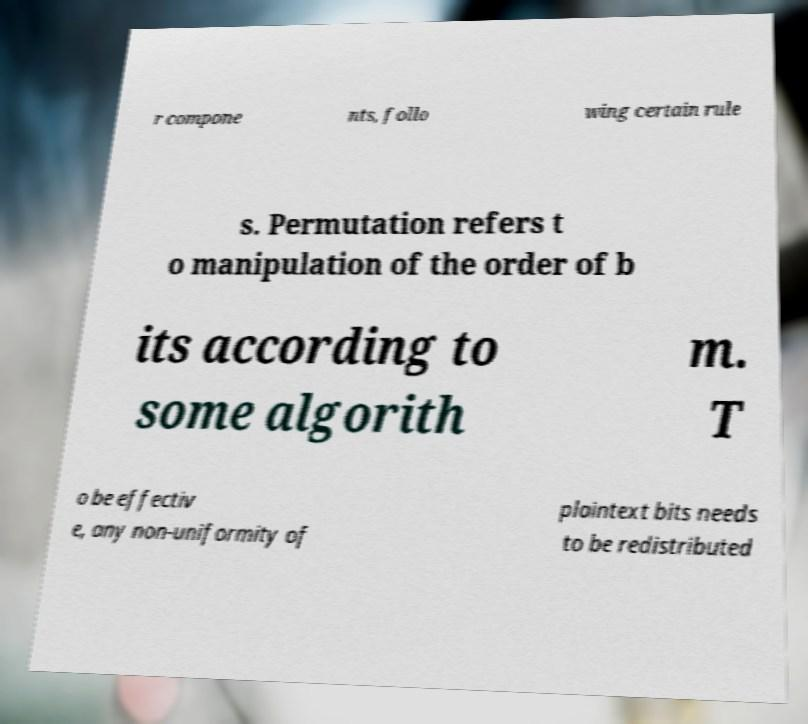What messages or text are displayed in this image? I need them in a readable, typed format. r compone nts, follo wing certain rule s. Permutation refers t o manipulation of the order of b its according to some algorith m. T o be effectiv e, any non-uniformity of plaintext bits needs to be redistributed 